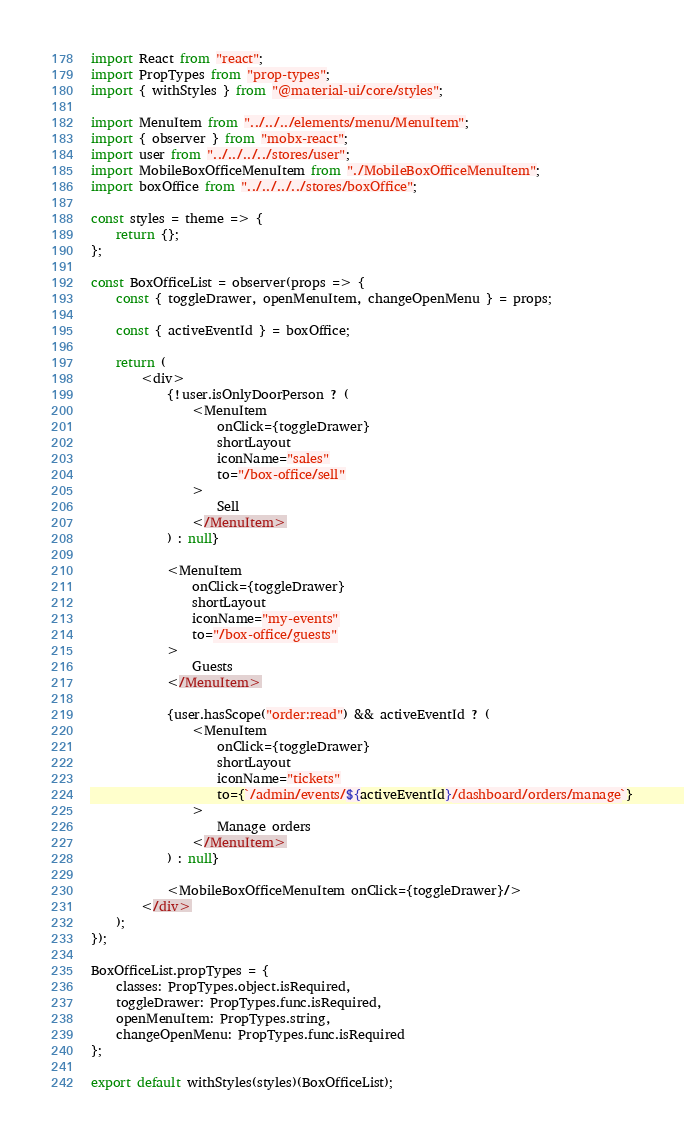<code> <loc_0><loc_0><loc_500><loc_500><_JavaScript_>import React from "react";
import PropTypes from "prop-types";
import { withStyles } from "@material-ui/core/styles";

import MenuItem from "../../../elements/menu/MenuItem";
import { observer } from "mobx-react";
import user from "../../../../stores/user";
import MobileBoxOfficeMenuItem from "./MobileBoxOfficeMenuItem";
import boxOffice from "../../../../stores/boxOffice";

const styles = theme => {
	return {};
};

const BoxOfficeList = observer(props => {
	const { toggleDrawer, openMenuItem, changeOpenMenu } = props;

	const { activeEventId } = boxOffice;

	return (
		<div>
			{!user.isOnlyDoorPerson ? (
				<MenuItem
					onClick={toggleDrawer}
					shortLayout
					iconName="sales"
					to="/box-office/sell"
				>
					Sell
				</MenuItem>
			) : null}

			<MenuItem
				onClick={toggleDrawer}
				shortLayout
				iconName="my-events"
				to="/box-office/guests"
			>
				Guests
			</MenuItem>

			{user.hasScope("order:read") && activeEventId ? (
				<MenuItem
					onClick={toggleDrawer}
					shortLayout
					iconName="tickets"
					to={`/admin/events/${activeEventId}/dashboard/orders/manage`}
				>
					Manage orders
				</MenuItem>
			) : null}

			<MobileBoxOfficeMenuItem onClick={toggleDrawer}/>
		</div>
	);
});

BoxOfficeList.propTypes = {
	classes: PropTypes.object.isRequired,
	toggleDrawer: PropTypes.func.isRequired,
	openMenuItem: PropTypes.string,
	changeOpenMenu: PropTypes.func.isRequired
};

export default withStyles(styles)(BoxOfficeList);
</code> 